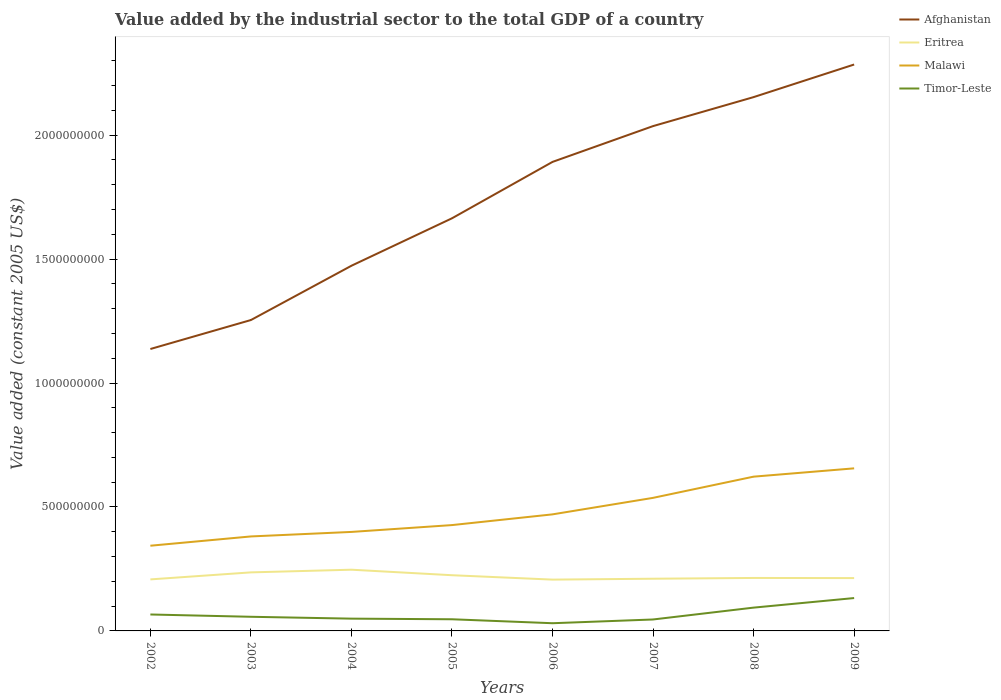How many different coloured lines are there?
Offer a very short reply. 4. Is the number of lines equal to the number of legend labels?
Ensure brevity in your answer.  Yes. Across all years, what is the maximum value added by the industrial sector in Afghanistan?
Your response must be concise. 1.14e+09. What is the total value added by the industrial sector in Timor-Leste in the graph?
Give a very brief answer. -8.56e+07. What is the difference between the highest and the second highest value added by the industrial sector in Afghanistan?
Offer a terse response. 1.15e+09. What is the difference between the highest and the lowest value added by the industrial sector in Timor-Leste?
Your response must be concise. 3. How many years are there in the graph?
Give a very brief answer. 8. What is the difference between two consecutive major ticks on the Y-axis?
Give a very brief answer. 5.00e+08. Are the values on the major ticks of Y-axis written in scientific E-notation?
Keep it short and to the point. No. Does the graph contain any zero values?
Your response must be concise. No. What is the title of the graph?
Make the answer very short. Value added by the industrial sector to the total GDP of a country. What is the label or title of the X-axis?
Offer a terse response. Years. What is the label or title of the Y-axis?
Provide a succinct answer. Value added (constant 2005 US$). What is the Value added (constant 2005 US$) of Afghanistan in 2002?
Offer a terse response. 1.14e+09. What is the Value added (constant 2005 US$) of Eritrea in 2002?
Offer a very short reply. 2.08e+08. What is the Value added (constant 2005 US$) of Malawi in 2002?
Keep it short and to the point. 3.44e+08. What is the Value added (constant 2005 US$) of Timor-Leste in 2002?
Keep it short and to the point. 6.63e+07. What is the Value added (constant 2005 US$) of Afghanistan in 2003?
Your answer should be compact. 1.25e+09. What is the Value added (constant 2005 US$) in Eritrea in 2003?
Make the answer very short. 2.36e+08. What is the Value added (constant 2005 US$) of Malawi in 2003?
Make the answer very short. 3.81e+08. What is the Value added (constant 2005 US$) in Timor-Leste in 2003?
Ensure brevity in your answer.  5.71e+07. What is the Value added (constant 2005 US$) of Afghanistan in 2004?
Your response must be concise. 1.47e+09. What is the Value added (constant 2005 US$) of Eritrea in 2004?
Offer a very short reply. 2.47e+08. What is the Value added (constant 2005 US$) of Malawi in 2004?
Provide a succinct answer. 3.99e+08. What is the Value added (constant 2005 US$) in Timor-Leste in 2004?
Your response must be concise. 4.95e+07. What is the Value added (constant 2005 US$) of Afghanistan in 2005?
Your response must be concise. 1.66e+09. What is the Value added (constant 2005 US$) of Eritrea in 2005?
Ensure brevity in your answer.  2.25e+08. What is the Value added (constant 2005 US$) in Malawi in 2005?
Keep it short and to the point. 4.27e+08. What is the Value added (constant 2005 US$) of Timor-Leste in 2005?
Provide a succinct answer. 4.70e+07. What is the Value added (constant 2005 US$) in Afghanistan in 2006?
Offer a very short reply. 1.89e+09. What is the Value added (constant 2005 US$) of Eritrea in 2006?
Make the answer very short. 2.07e+08. What is the Value added (constant 2005 US$) of Malawi in 2006?
Provide a short and direct response. 4.70e+08. What is the Value added (constant 2005 US$) in Timor-Leste in 2006?
Your answer should be very brief. 3.11e+07. What is the Value added (constant 2005 US$) of Afghanistan in 2007?
Provide a short and direct response. 2.04e+09. What is the Value added (constant 2005 US$) of Eritrea in 2007?
Make the answer very short. 2.11e+08. What is the Value added (constant 2005 US$) in Malawi in 2007?
Your answer should be very brief. 5.37e+08. What is the Value added (constant 2005 US$) of Timor-Leste in 2007?
Ensure brevity in your answer.  4.62e+07. What is the Value added (constant 2005 US$) of Afghanistan in 2008?
Offer a terse response. 2.15e+09. What is the Value added (constant 2005 US$) in Eritrea in 2008?
Ensure brevity in your answer.  2.14e+08. What is the Value added (constant 2005 US$) in Malawi in 2008?
Your answer should be compact. 6.22e+08. What is the Value added (constant 2005 US$) of Timor-Leste in 2008?
Keep it short and to the point. 9.40e+07. What is the Value added (constant 2005 US$) of Afghanistan in 2009?
Provide a succinct answer. 2.29e+09. What is the Value added (constant 2005 US$) of Eritrea in 2009?
Provide a succinct answer. 2.13e+08. What is the Value added (constant 2005 US$) of Malawi in 2009?
Give a very brief answer. 6.56e+08. What is the Value added (constant 2005 US$) of Timor-Leste in 2009?
Ensure brevity in your answer.  1.33e+08. Across all years, what is the maximum Value added (constant 2005 US$) of Afghanistan?
Offer a very short reply. 2.29e+09. Across all years, what is the maximum Value added (constant 2005 US$) in Eritrea?
Make the answer very short. 2.47e+08. Across all years, what is the maximum Value added (constant 2005 US$) in Malawi?
Provide a short and direct response. 6.56e+08. Across all years, what is the maximum Value added (constant 2005 US$) in Timor-Leste?
Your response must be concise. 1.33e+08. Across all years, what is the minimum Value added (constant 2005 US$) in Afghanistan?
Provide a short and direct response. 1.14e+09. Across all years, what is the minimum Value added (constant 2005 US$) in Eritrea?
Your response must be concise. 2.07e+08. Across all years, what is the minimum Value added (constant 2005 US$) in Malawi?
Your response must be concise. 3.44e+08. Across all years, what is the minimum Value added (constant 2005 US$) of Timor-Leste?
Your answer should be compact. 3.11e+07. What is the total Value added (constant 2005 US$) in Afghanistan in the graph?
Ensure brevity in your answer.  1.39e+1. What is the total Value added (constant 2005 US$) in Eritrea in the graph?
Provide a succinct answer. 1.76e+09. What is the total Value added (constant 2005 US$) in Malawi in the graph?
Offer a terse response. 3.84e+09. What is the total Value added (constant 2005 US$) of Timor-Leste in the graph?
Offer a terse response. 5.24e+08. What is the difference between the Value added (constant 2005 US$) of Afghanistan in 2002 and that in 2003?
Offer a terse response. -1.17e+08. What is the difference between the Value added (constant 2005 US$) in Eritrea in 2002 and that in 2003?
Provide a short and direct response. -2.83e+07. What is the difference between the Value added (constant 2005 US$) in Malawi in 2002 and that in 2003?
Offer a very short reply. -3.75e+07. What is the difference between the Value added (constant 2005 US$) in Timor-Leste in 2002 and that in 2003?
Keep it short and to the point. 9.23e+06. What is the difference between the Value added (constant 2005 US$) of Afghanistan in 2002 and that in 2004?
Ensure brevity in your answer.  -3.36e+08. What is the difference between the Value added (constant 2005 US$) in Eritrea in 2002 and that in 2004?
Keep it short and to the point. -3.91e+07. What is the difference between the Value added (constant 2005 US$) of Malawi in 2002 and that in 2004?
Offer a terse response. -5.57e+07. What is the difference between the Value added (constant 2005 US$) in Timor-Leste in 2002 and that in 2004?
Offer a very short reply. 1.68e+07. What is the difference between the Value added (constant 2005 US$) in Afghanistan in 2002 and that in 2005?
Provide a succinct answer. -5.27e+08. What is the difference between the Value added (constant 2005 US$) in Eritrea in 2002 and that in 2005?
Offer a very short reply. -1.69e+07. What is the difference between the Value added (constant 2005 US$) in Malawi in 2002 and that in 2005?
Keep it short and to the point. -8.33e+07. What is the difference between the Value added (constant 2005 US$) in Timor-Leste in 2002 and that in 2005?
Ensure brevity in your answer.  1.93e+07. What is the difference between the Value added (constant 2005 US$) of Afghanistan in 2002 and that in 2006?
Keep it short and to the point. -7.55e+08. What is the difference between the Value added (constant 2005 US$) in Eritrea in 2002 and that in 2006?
Your answer should be very brief. 8.30e+05. What is the difference between the Value added (constant 2005 US$) in Malawi in 2002 and that in 2006?
Make the answer very short. -1.27e+08. What is the difference between the Value added (constant 2005 US$) of Timor-Leste in 2002 and that in 2006?
Your answer should be very brief. 3.52e+07. What is the difference between the Value added (constant 2005 US$) of Afghanistan in 2002 and that in 2007?
Provide a succinct answer. -8.99e+08. What is the difference between the Value added (constant 2005 US$) of Eritrea in 2002 and that in 2007?
Offer a terse response. -2.76e+06. What is the difference between the Value added (constant 2005 US$) of Malawi in 2002 and that in 2007?
Your answer should be very brief. -1.93e+08. What is the difference between the Value added (constant 2005 US$) in Timor-Leste in 2002 and that in 2007?
Offer a very short reply. 2.01e+07. What is the difference between the Value added (constant 2005 US$) of Afghanistan in 2002 and that in 2008?
Your answer should be compact. -1.02e+09. What is the difference between the Value added (constant 2005 US$) of Eritrea in 2002 and that in 2008?
Keep it short and to the point. -5.80e+06. What is the difference between the Value added (constant 2005 US$) of Malawi in 2002 and that in 2008?
Your response must be concise. -2.79e+08. What is the difference between the Value added (constant 2005 US$) of Timor-Leste in 2002 and that in 2008?
Your answer should be compact. -2.77e+07. What is the difference between the Value added (constant 2005 US$) in Afghanistan in 2002 and that in 2009?
Offer a terse response. -1.15e+09. What is the difference between the Value added (constant 2005 US$) of Eritrea in 2002 and that in 2009?
Your answer should be very brief. -5.29e+06. What is the difference between the Value added (constant 2005 US$) in Malawi in 2002 and that in 2009?
Make the answer very short. -3.12e+08. What is the difference between the Value added (constant 2005 US$) of Timor-Leste in 2002 and that in 2009?
Keep it short and to the point. -6.63e+07. What is the difference between the Value added (constant 2005 US$) of Afghanistan in 2003 and that in 2004?
Make the answer very short. -2.19e+08. What is the difference between the Value added (constant 2005 US$) in Eritrea in 2003 and that in 2004?
Make the answer very short. -1.08e+07. What is the difference between the Value added (constant 2005 US$) of Malawi in 2003 and that in 2004?
Offer a very short reply. -1.82e+07. What is the difference between the Value added (constant 2005 US$) in Timor-Leste in 2003 and that in 2004?
Offer a very short reply. 7.55e+06. What is the difference between the Value added (constant 2005 US$) in Afghanistan in 2003 and that in 2005?
Make the answer very short. -4.11e+08. What is the difference between the Value added (constant 2005 US$) of Eritrea in 2003 and that in 2005?
Offer a very short reply. 1.14e+07. What is the difference between the Value added (constant 2005 US$) in Malawi in 2003 and that in 2005?
Provide a short and direct response. -4.58e+07. What is the difference between the Value added (constant 2005 US$) in Timor-Leste in 2003 and that in 2005?
Give a very brief answer. 1.01e+07. What is the difference between the Value added (constant 2005 US$) of Afghanistan in 2003 and that in 2006?
Offer a terse response. -6.38e+08. What is the difference between the Value added (constant 2005 US$) in Eritrea in 2003 and that in 2006?
Provide a short and direct response. 2.92e+07. What is the difference between the Value added (constant 2005 US$) of Malawi in 2003 and that in 2006?
Your answer should be compact. -8.91e+07. What is the difference between the Value added (constant 2005 US$) of Timor-Leste in 2003 and that in 2006?
Ensure brevity in your answer.  2.60e+07. What is the difference between the Value added (constant 2005 US$) in Afghanistan in 2003 and that in 2007?
Provide a short and direct response. -7.83e+08. What is the difference between the Value added (constant 2005 US$) in Eritrea in 2003 and that in 2007?
Provide a succinct answer. 2.56e+07. What is the difference between the Value added (constant 2005 US$) of Malawi in 2003 and that in 2007?
Your answer should be very brief. -1.56e+08. What is the difference between the Value added (constant 2005 US$) of Timor-Leste in 2003 and that in 2007?
Your response must be concise. 1.09e+07. What is the difference between the Value added (constant 2005 US$) of Afghanistan in 2003 and that in 2008?
Your answer should be very brief. -8.99e+08. What is the difference between the Value added (constant 2005 US$) in Eritrea in 2003 and that in 2008?
Provide a short and direct response. 2.25e+07. What is the difference between the Value added (constant 2005 US$) of Malawi in 2003 and that in 2008?
Provide a short and direct response. -2.41e+08. What is the difference between the Value added (constant 2005 US$) of Timor-Leste in 2003 and that in 2008?
Provide a succinct answer. -3.69e+07. What is the difference between the Value added (constant 2005 US$) of Afghanistan in 2003 and that in 2009?
Make the answer very short. -1.03e+09. What is the difference between the Value added (constant 2005 US$) in Eritrea in 2003 and that in 2009?
Provide a short and direct response. 2.30e+07. What is the difference between the Value added (constant 2005 US$) in Malawi in 2003 and that in 2009?
Make the answer very short. -2.75e+08. What is the difference between the Value added (constant 2005 US$) in Timor-Leste in 2003 and that in 2009?
Your answer should be compact. -7.55e+07. What is the difference between the Value added (constant 2005 US$) of Afghanistan in 2004 and that in 2005?
Keep it short and to the point. -1.91e+08. What is the difference between the Value added (constant 2005 US$) of Eritrea in 2004 and that in 2005?
Provide a succinct answer. 2.22e+07. What is the difference between the Value added (constant 2005 US$) of Malawi in 2004 and that in 2005?
Offer a very short reply. -2.76e+07. What is the difference between the Value added (constant 2005 US$) of Timor-Leste in 2004 and that in 2005?
Your answer should be compact. 2.52e+06. What is the difference between the Value added (constant 2005 US$) of Afghanistan in 2004 and that in 2006?
Provide a short and direct response. -4.19e+08. What is the difference between the Value added (constant 2005 US$) in Eritrea in 2004 and that in 2006?
Ensure brevity in your answer.  4.00e+07. What is the difference between the Value added (constant 2005 US$) of Malawi in 2004 and that in 2006?
Provide a succinct answer. -7.08e+07. What is the difference between the Value added (constant 2005 US$) of Timor-Leste in 2004 and that in 2006?
Make the answer very short. 1.85e+07. What is the difference between the Value added (constant 2005 US$) of Afghanistan in 2004 and that in 2007?
Provide a short and direct response. -5.63e+08. What is the difference between the Value added (constant 2005 US$) in Eritrea in 2004 and that in 2007?
Your answer should be compact. 3.64e+07. What is the difference between the Value added (constant 2005 US$) in Malawi in 2004 and that in 2007?
Provide a succinct answer. -1.37e+08. What is the difference between the Value added (constant 2005 US$) in Timor-Leste in 2004 and that in 2007?
Your response must be concise. 3.36e+06. What is the difference between the Value added (constant 2005 US$) in Afghanistan in 2004 and that in 2008?
Your answer should be compact. -6.80e+08. What is the difference between the Value added (constant 2005 US$) of Eritrea in 2004 and that in 2008?
Your answer should be very brief. 3.33e+07. What is the difference between the Value added (constant 2005 US$) in Malawi in 2004 and that in 2008?
Ensure brevity in your answer.  -2.23e+08. What is the difference between the Value added (constant 2005 US$) of Timor-Leste in 2004 and that in 2008?
Your response must be concise. -4.45e+07. What is the difference between the Value added (constant 2005 US$) of Afghanistan in 2004 and that in 2009?
Ensure brevity in your answer.  -8.12e+08. What is the difference between the Value added (constant 2005 US$) in Eritrea in 2004 and that in 2009?
Make the answer very short. 3.38e+07. What is the difference between the Value added (constant 2005 US$) of Malawi in 2004 and that in 2009?
Offer a very short reply. -2.57e+08. What is the difference between the Value added (constant 2005 US$) of Timor-Leste in 2004 and that in 2009?
Make the answer very short. -8.31e+07. What is the difference between the Value added (constant 2005 US$) in Afghanistan in 2005 and that in 2006?
Give a very brief answer. -2.28e+08. What is the difference between the Value added (constant 2005 US$) of Eritrea in 2005 and that in 2006?
Keep it short and to the point. 1.77e+07. What is the difference between the Value added (constant 2005 US$) in Malawi in 2005 and that in 2006?
Give a very brief answer. -4.33e+07. What is the difference between the Value added (constant 2005 US$) of Timor-Leste in 2005 and that in 2006?
Make the answer very short. 1.59e+07. What is the difference between the Value added (constant 2005 US$) in Afghanistan in 2005 and that in 2007?
Offer a very short reply. -3.72e+08. What is the difference between the Value added (constant 2005 US$) of Eritrea in 2005 and that in 2007?
Provide a succinct answer. 1.41e+07. What is the difference between the Value added (constant 2005 US$) of Malawi in 2005 and that in 2007?
Ensure brevity in your answer.  -1.10e+08. What is the difference between the Value added (constant 2005 US$) in Timor-Leste in 2005 and that in 2007?
Your response must be concise. 8.39e+05. What is the difference between the Value added (constant 2005 US$) of Afghanistan in 2005 and that in 2008?
Your answer should be very brief. -4.89e+08. What is the difference between the Value added (constant 2005 US$) in Eritrea in 2005 and that in 2008?
Offer a terse response. 1.11e+07. What is the difference between the Value added (constant 2005 US$) in Malawi in 2005 and that in 2008?
Your answer should be compact. -1.95e+08. What is the difference between the Value added (constant 2005 US$) in Timor-Leste in 2005 and that in 2008?
Give a very brief answer. -4.70e+07. What is the difference between the Value added (constant 2005 US$) in Afghanistan in 2005 and that in 2009?
Offer a terse response. -6.20e+08. What is the difference between the Value added (constant 2005 US$) of Eritrea in 2005 and that in 2009?
Ensure brevity in your answer.  1.16e+07. What is the difference between the Value added (constant 2005 US$) of Malawi in 2005 and that in 2009?
Keep it short and to the point. -2.29e+08. What is the difference between the Value added (constant 2005 US$) of Timor-Leste in 2005 and that in 2009?
Make the answer very short. -8.56e+07. What is the difference between the Value added (constant 2005 US$) in Afghanistan in 2006 and that in 2007?
Offer a terse response. -1.44e+08. What is the difference between the Value added (constant 2005 US$) of Eritrea in 2006 and that in 2007?
Offer a terse response. -3.59e+06. What is the difference between the Value added (constant 2005 US$) in Malawi in 2006 and that in 2007?
Provide a succinct answer. -6.66e+07. What is the difference between the Value added (constant 2005 US$) of Timor-Leste in 2006 and that in 2007?
Give a very brief answer. -1.51e+07. What is the difference between the Value added (constant 2005 US$) in Afghanistan in 2006 and that in 2008?
Make the answer very short. -2.61e+08. What is the difference between the Value added (constant 2005 US$) in Eritrea in 2006 and that in 2008?
Provide a succinct answer. -6.63e+06. What is the difference between the Value added (constant 2005 US$) of Malawi in 2006 and that in 2008?
Your answer should be very brief. -1.52e+08. What is the difference between the Value added (constant 2005 US$) in Timor-Leste in 2006 and that in 2008?
Your answer should be compact. -6.29e+07. What is the difference between the Value added (constant 2005 US$) in Afghanistan in 2006 and that in 2009?
Provide a short and direct response. -3.93e+08. What is the difference between the Value added (constant 2005 US$) in Eritrea in 2006 and that in 2009?
Give a very brief answer. -6.12e+06. What is the difference between the Value added (constant 2005 US$) in Malawi in 2006 and that in 2009?
Provide a succinct answer. -1.86e+08. What is the difference between the Value added (constant 2005 US$) in Timor-Leste in 2006 and that in 2009?
Make the answer very short. -1.02e+08. What is the difference between the Value added (constant 2005 US$) of Afghanistan in 2007 and that in 2008?
Offer a terse response. -1.17e+08. What is the difference between the Value added (constant 2005 US$) of Eritrea in 2007 and that in 2008?
Provide a succinct answer. -3.04e+06. What is the difference between the Value added (constant 2005 US$) of Malawi in 2007 and that in 2008?
Provide a short and direct response. -8.56e+07. What is the difference between the Value added (constant 2005 US$) in Timor-Leste in 2007 and that in 2008?
Offer a terse response. -4.78e+07. What is the difference between the Value added (constant 2005 US$) of Afghanistan in 2007 and that in 2009?
Give a very brief answer. -2.48e+08. What is the difference between the Value added (constant 2005 US$) of Eritrea in 2007 and that in 2009?
Offer a very short reply. -2.52e+06. What is the difference between the Value added (constant 2005 US$) in Malawi in 2007 and that in 2009?
Keep it short and to the point. -1.19e+08. What is the difference between the Value added (constant 2005 US$) in Timor-Leste in 2007 and that in 2009?
Keep it short and to the point. -8.64e+07. What is the difference between the Value added (constant 2005 US$) in Afghanistan in 2008 and that in 2009?
Offer a terse response. -1.32e+08. What is the difference between the Value added (constant 2005 US$) of Eritrea in 2008 and that in 2009?
Make the answer very short. 5.18e+05. What is the difference between the Value added (constant 2005 US$) in Malawi in 2008 and that in 2009?
Provide a succinct answer. -3.35e+07. What is the difference between the Value added (constant 2005 US$) of Timor-Leste in 2008 and that in 2009?
Provide a succinct answer. -3.86e+07. What is the difference between the Value added (constant 2005 US$) of Afghanistan in 2002 and the Value added (constant 2005 US$) of Eritrea in 2003?
Your answer should be very brief. 9.01e+08. What is the difference between the Value added (constant 2005 US$) of Afghanistan in 2002 and the Value added (constant 2005 US$) of Malawi in 2003?
Give a very brief answer. 7.56e+08. What is the difference between the Value added (constant 2005 US$) in Afghanistan in 2002 and the Value added (constant 2005 US$) in Timor-Leste in 2003?
Your answer should be very brief. 1.08e+09. What is the difference between the Value added (constant 2005 US$) in Eritrea in 2002 and the Value added (constant 2005 US$) in Malawi in 2003?
Keep it short and to the point. -1.73e+08. What is the difference between the Value added (constant 2005 US$) in Eritrea in 2002 and the Value added (constant 2005 US$) in Timor-Leste in 2003?
Your response must be concise. 1.51e+08. What is the difference between the Value added (constant 2005 US$) in Malawi in 2002 and the Value added (constant 2005 US$) in Timor-Leste in 2003?
Ensure brevity in your answer.  2.87e+08. What is the difference between the Value added (constant 2005 US$) in Afghanistan in 2002 and the Value added (constant 2005 US$) in Eritrea in 2004?
Ensure brevity in your answer.  8.90e+08. What is the difference between the Value added (constant 2005 US$) in Afghanistan in 2002 and the Value added (constant 2005 US$) in Malawi in 2004?
Make the answer very short. 7.38e+08. What is the difference between the Value added (constant 2005 US$) in Afghanistan in 2002 and the Value added (constant 2005 US$) in Timor-Leste in 2004?
Offer a very short reply. 1.09e+09. What is the difference between the Value added (constant 2005 US$) of Eritrea in 2002 and the Value added (constant 2005 US$) of Malawi in 2004?
Make the answer very short. -1.92e+08. What is the difference between the Value added (constant 2005 US$) of Eritrea in 2002 and the Value added (constant 2005 US$) of Timor-Leste in 2004?
Keep it short and to the point. 1.58e+08. What is the difference between the Value added (constant 2005 US$) in Malawi in 2002 and the Value added (constant 2005 US$) in Timor-Leste in 2004?
Your answer should be very brief. 2.94e+08. What is the difference between the Value added (constant 2005 US$) of Afghanistan in 2002 and the Value added (constant 2005 US$) of Eritrea in 2005?
Provide a short and direct response. 9.13e+08. What is the difference between the Value added (constant 2005 US$) of Afghanistan in 2002 and the Value added (constant 2005 US$) of Malawi in 2005?
Your response must be concise. 7.10e+08. What is the difference between the Value added (constant 2005 US$) in Afghanistan in 2002 and the Value added (constant 2005 US$) in Timor-Leste in 2005?
Keep it short and to the point. 1.09e+09. What is the difference between the Value added (constant 2005 US$) of Eritrea in 2002 and the Value added (constant 2005 US$) of Malawi in 2005?
Your answer should be very brief. -2.19e+08. What is the difference between the Value added (constant 2005 US$) in Eritrea in 2002 and the Value added (constant 2005 US$) in Timor-Leste in 2005?
Provide a short and direct response. 1.61e+08. What is the difference between the Value added (constant 2005 US$) in Malawi in 2002 and the Value added (constant 2005 US$) in Timor-Leste in 2005?
Offer a very short reply. 2.97e+08. What is the difference between the Value added (constant 2005 US$) in Afghanistan in 2002 and the Value added (constant 2005 US$) in Eritrea in 2006?
Ensure brevity in your answer.  9.30e+08. What is the difference between the Value added (constant 2005 US$) of Afghanistan in 2002 and the Value added (constant 2005 US$) of Malawi in 2006?
Offer a very short reply. 6.67e+08. What is the difference between the Value added (constant 2005 US$) in Afghanistan in 2002 and the Value added (constant 2005 US$) in Timor-Leste in 2006?
Make the answer very short. 1.11e+09. What is the difference between the Value added (constant 2005 US$) in Eritrea in 2002 and the Value added (constant 2005 US$) in Malawi in 2006?
Your answer should be compact. -2.62e+08. What is the difference between the Value added (constant 2005 US$) of Eritrea in 2002 and the Value added (constant 2005 US$) of Timor-Leste in 2006?
Offer a terse response. 1.77e+08. What is the difference between the Value added (constant 2005 US$) of Malawi in 2002 and the Value added (constant 2005 US$) of Timor-Leste in 2006?
Your answer should be compact. 3.13e+08. What is the difference between the Value added (constant 2005 US$) of Afghanistan in 2002 and the Value added (constant 2005 US$) of Eritrea in 2007?
Ensure brevity in your answer.  9.27e+08. What is the difference between the Value added (constant 2005 US$) of Afghanistan in 2002 and the Value added (constant 2005 US$) of Malawi in 2007?
Your response must be concise. 6.01e+08. What is the difference between the Value added (constant 2005 US$) in Afghanistan in 2002 and the Value added (constant 2005 US$) in Timor-Leste in 2007?
Give a very brief answer. 1.09e+09. What is the difference between the Value added (constant 2005 US$) in Eritrea in 2002 and the Value added (constant 2005 US$) in Malawi in 2007?
Offer a very short reply. -3.29e+08. What is the difference between the Value added (constant 2005 US$) in Eritrea in 2002 and the Value added (constant 2005 US$) in Timor-Leste in 2007?
Provide a short and direct response. 1.62e+08. What is the difference between the Value added (constant 2005 US$) of Malawi in 2002 and the Value added (constant 2005 US$) of Timor-Leste in 2007?
Your response must be concise. 2.98e+08. What is the difference between the Value added (constant 2005 US$) of Afghanistan in 2002 and the Value added (constant 2005 US$) of Eritrea in 2008?
Make the answer very short. 9.24e+08. What is the difference between the Value added (constant 2005 US$) of Afghanistan in 2002 and the Value added (constant 2005 US$) of Malawi in 2008?
Provide a succinct answer. 5.15e+08. What is the difference between the Value added (constant 2005 US$) of Afghanistan in 2002 and the Value added (constant 2005 US$) of Timor-Leste in 2008?
Keep it short and to the point. 1.04e+09. What is the difference between the Value added (constant 2005 US$) of Eritrea in 2002 and the Value added (constant 2005 US$) of Malawi in 2008?
Provide a short and direct response. -4.15e+08. What is the difference between the Value added (constant 2005 US$) in Eritrea in 2002 and the Value added (constant 2005 US$) in Timor-Leste in 2008?
Offer a terse response. 1.14e+08. What is the difference between the Value added (constant 2005 US$) of Malawi in 2002 and the Value added (constant 2005 US$) of Timor-Leste in 2008?
Ensure brevity in your answer.  2.50e+08. What is the difference between the Value added (constant 2005 US$) of Afghanistan in 2002 and the Value added (constant 2005 US$) of Eritrea in 2009?
Your answer should be very brief. 9.24e+08. What is the difference between the Value added (constant 2005 US$) in Afghanistan in 2002 and the Value added (constant 2005 US$) in Malawi in 2009?
Keep it short and to the point. 4.81e+08. What is the difference between the Value added (constant 2005 US$) of Afghanistan in 2002 and the Value added (constant 2005 US$) of Timor-Leste in 2009?
Your answer should be compact. 1.00e+09. What is the difference between the Value added (constant 2005 US$) of Eritrea in 2002 and the Value added (constant 2005 US$) of Malawi in 2009?
Offer a very short reply. -4.48e+08. What is the difference between the Value added (constant 2005 US$) of Eritrea in 2002 and the Value added (constant 2005 US$) of Timor-Leste in 2009?
Your answer should be very brief. 7.53e+07. What is the difference between the Value added (constant 2005 US$) in Malawi in 2002 and the Value added (constant 2005 US$) in Timor-Leste in 2009?
Give a very brief answer. 2.11e+08. What is the difference between the Value added (constant 2005 US$) in Afghanistan in 2003 and the Value added (constant 2005 US$) in Eritrea in 2004?
Provide a succinct answer. 1.01e+09. What is the difference between the Value added (constant 2005 US$) in Afghanistan in 2003 and the Value added (constant 2005 US$) in Malawi in 2004?
Your response must be concise. 8.55e+08. What is the difference between the Value added (constant 2005 US$) in Afghanistan in 2003 and the Value added (constant 2005 US$) in Timor-Leste in 2004?
Your answer should be compact. 1.20e+09. What is the difference between the Value added (constant 2005 US$) in Eritrea in 2003 and the Value added (constant 2005 US$) in Malawi in 2004?
Your response must be concise. -1.63e+08. What is the difference between the Value added (constant 2005 US$) of Eritrea in 2003 and the Value added (constant 2005 US$) of Timor-Leste in 2004?
Offer a very short reply. 1.87e+08. What is the difference between the Value added (constant 2005 US$) in Malawi in 2003 and the Value added (constant 2005 US$) in Timor-Leste in 2004?
Offer a terse response. 3.32e+08. What is the difference between the Value added (constant 2005 US$) in Afghanistan in 2003 and the Value added (constant 2005 US$) in Eritrea in 2005?
Offer a very short reply. 1.03e+09. What is the difference between the Value added (constant 2005 US$) of Afghanistan in 2003 and the Value added (constant 2005 US$) of Malawi in 2005?
Your answer should be compact. 8.27e+08. What is the difference between the Value added (constant 2005 US$) of Afghanistan in 2003 and the Value added (constant 2005 US$) of Timor-Leste in 2005?
Keep it short and to the point. 1.21e+09. What is the difference between the Value added (constant 2005 US$) of Eritrea in 2003 and the Value added (constant 2005 US$) of Malawi in 2005?
Keep it short and to the point. -1.91e+08. What is the difference between the Value added (constant 2005 US$) in Eritrea in 2003 and the Value added (constant 2005 US$) in Timor-Leste in 2005?
Keep it short and to the point. 1.89e+08. What is the difference between the Value added (constant 2005 US$) of Malawi in 2003 and the Value added (constant 2005 US$) of Timor-Leste in 2005?
Offer a terse response. 3.34e+08. What is the difference between the Value added (constant 2005 US$) in Afghanistan in 2003 and the Value added (constant 2005 US$) in Eritrea in 2006?
Your answer should be very brief. 1.05e+09. What is the difference between the Value added (constant 2005 US$) of Afghanistan in 2003 and the Value added (constant 2005 US$) of Malawi in 2006?
Provide a succinct answer. 7.84e+08. What is the difference between the Value added (constant 2005 US$) in Afghanistan in 2003 and the Value added (constant 2005 US$) in Timor-Leste in 2006?
Ensure brevity in your answer.  1.22e+09. What is the difference between the Value added (constant 2005 US$) of Eritrea in 2003 and the Value added (constant 2005 US$) of Malawi in 2006?
Provide a succinct answer. -2.34e+08. What is the difference between the Value added (constant 2005 US$) in Eritrea in 2003 and the Value added (constant 2005 US$) in Timor-Leste in 2006?
Provide a succinct answer. 2.05e+08. What is the difference between the Value added (constant 2005 US$) in Malawi in 2003 and the Value added (constant 2005 US$) in Timor-Leste in 2006?
Provide a succinct answer. 3.50e+08. What is the difference between the Value added (constant 2005 US$) of Afghanistan in 2003 and the Value added (constant 2005 US$) of Eritrea in 2007?
Your answer should be very brief. 1.04e+09. What is the difference between the Value added (constant 2005 US$) in Afghanistan in 2003 and the Value added (constant 2005 US$) in Malawi in 2007?
Keep it short and to the point. 7.17e+08. What is the difference between the Value added (constant 2005 US$) of Afghanistan in 2003 and the Value added (constant 2005 US$) of Timor-Leste in 2007?
Keep it short and to the point. 1.21e+09. What is the difference between the Value added (constant 2005 US$) in Eritrea in 2003 and the Value added (constant 2005 US$) in Malawi in 2007?
Make the answer very short. -3.01e+08. What is the difference between the Value added (constant 2005 US$) of Eritrea in 2003 and the Value added (constant 2005 US$) of Timor-Leste in 2007?
Provide a short and direct response. 1.90e+08. What is the difference between the Value added (constant 2005 US$) in Malawi in 2003 and the Value added (constant 2005 US$) in Timor-Leste in 2007?
Offer a terse response. 3.35e+08. What is the difference between the Value added (constant 2005 US$) in Afghanistan in 2003 and the Value added (constant 2005 US$) in Eritrea in 2008?
Ensure brevity in your answer.  1.04e+09. What is the difference between the Value added (constant 2005 US$) of Afghanistan in 2003 and the Value added (constant 2005 US$) of Malawi in 2008?
Keep it short and to the point. 6.32e+08. What is the difference between the Value added (constant 2005 US$) in Afghanistan in 2003 and the Value added (constant 2005 US$) in Timor-Leste in 2008?
Offer a terse response. 1.16e+09. What is the difference between the Value added (constant 2005 US$) of Eritrea in 2003 and the Value added (constant 2005 US$) of Malawi in 2008?
Offer a very short reply. -3.86e+08. What is the difference between the Value added (constant 2005 US$) in Eritrea in 2003 and the Value added (constant 2005 US$) in Timor-Leste in 2008?
Make the answer very short. 1.42e+08. What is the difference between the Value added (constant 2005 US$) of Malawi in 2003 and the Value added (constant 2005 US$) of Timor-Leste in 2008?
Ensure brevity in your answer.  2.87e+08. What is the difference between the Value added (constant 2005 US$) of Afghanistan in 2003 and the Value added (constant 2005 US$) of Eritrea in 2009?
Make the answer very short. 1.04e+09. What is the difference between the Value added (constant 2005 US$) in Afghanistan in 2003 and the Value added (constant 2005 US$) in Malawi in 2009?
Ensure brevity in your answer.  5.98e+08. What is the difference between the Value added (constant 2005 US$) of Afghanistan in 2003 and the Value added (constant 2005 US$) of Timor-Leste in 2009?
Offer a terse response. 1.12e+09. What is the difference between the Value added (constant 2005 US$) of Eritrea in 2003 and the Value added (constant 2005 US$) of Malawi in 2009?
Make the answer very short. -4.20e+08. What is the difference between the Value added (constant 2005 US$) of Eritrea in 2003 and the Value added (constant 2005 US$) of Timor-Leste in 2009?
Keep it short and to the point. 1.04e+08. What is the difference between the Value added (constant 2005 US$) in Malawi in 2003 and the Value added (constant 2005 US$) in Timor-Leste in 2009?
Give a very brief answer. 2.49e+08. What is the difference between the Value added (constant 2005 US$) of Afghanistan in 2004 and the Value added (constant 2005 US$) of Eritrea in 2005?
Offer a terse response. 1.25e+09. What is the difference between the Value added (constant 2005 US$) of Afghanistan in 2004 and the Value added (constant 2005 US$) of Malawi in 2005?
Provide a short and direct response. 1.05e+09. What is the difference between the Value added (constant 2005 US$) in Afghanistan in 2004 and the Value added (constant 2005 US$) in Timor-Leste in 2005?
Offer a very short reply. 1.43e+09. What is the difference between the Value added (constant 2005 US$) in Eritrea in 2004 and the Value added (constant 2005 US$) in Malawi in 2005?
Your response must be concise. -1.80e+08. What is the difference between the Value added (constant 2005 US$) of Eritrea in 2004 and the Value added (constant 2005 US$) of Timor-Leste in 2005?
Provide a short and direct response. 2.00e+08. What is the difference between the Value added (constant 2005 US$) in Malawi in 2004 and the Value added (constant 2005 US$) in Timor-Leste in 2005?
Offer a very short reply. 3.52e+08. What is the difference between the Value added (constant 2005 US$) in Afghanistan in 2004 and the Value added (constant 2005 US$) in Eritrea in 2006?
Offer a very short reply. 1.27e+09. What is the difference between the Value added (constant 2005 US$) in Afghanistan in 2004 and the Value added (constant 2005 US$) in Malawi in 2006?
Give a very brief answer. 1.00e+09. What is the difference between the Value added (constant 2005 US$) of Afghanistan in 2004 and the Value added (constant 2005 US$) of Timor-Leste in 2006?
Ensure brevity in your answer.  1.44e+09. What is the difference between the Value added (constant 2005 US$) of Eritrea in 2004 and the Value added (constant 2005 US$) of Malawi in 2006?
Your answer should be compact. -2.23e+08. What is the difference between the Value added (constant 2005 US$) in Eritrea in 2004 and the Value added (constant 2005 US$) in Timor-Leste in 2006?
Ensure brevity in your answer.  2.16e+08. What is the difference between the Value added (constant 2005 US$) of Malawi in 2004 and the Value added (constant 2005 US$) of Timor-Leste in 2006?
Give a very brief answer. 3.68e+08. What is the difference between the Value added (constant 2005 US$) in Afghanistan in 2004 and the Value added (constant 2005 US$) in Eritrea in 2007?
Offer a very short reply. 1.26e+09. What is the difference between the Value added (constant 2005 US$) of Afghanistan in 2004 and the Value added (constant 2005 US$) of Malawi in 2007?
Make the answer very short. 9.37e+08. What is the difference between the Value added (constant 2005 US$) of Afghanistan in 2004 and the Value added (constant 2005 US$) of Timor-Leste in 2007?
Your response must be concise. 1.43e+09. What is the difference between the Value added (constant 2005 US$) in Eritrea in 2004 and the Value added (constant 2005 US$) in Malawi in 2007?
Offer a terse response. -2.90e+08. What is the difference between the Value added (constant 2005 US$) in Eritrea in 2004 and the Value added (constant 2005 US$) in Timor-Leste in 2007?
Your answer should be very brief. 2.01e+08. What is the difference between the Value added (constant 2005 US$) in Malawi in 2004 and the Value added (constant 2005 US$) in Timor-Leste in 2007?
Your answer should be compact. 3.53e+08. What is the difference between the Value added (constant 2005 US$) of Afghanistan in 2004 and the Value added (constant 2005 US$) of Eritrea in 2008?
Offer a terse response. 1.26e+09. What is the difference between the Value added (constant 2005 US$) of Afghanistan in 2004 and the Value added (constant 2005 US$) of Malawi in 2008?
Keep it short and to the point. 8.51e+08. What is the difference between the Value added (constant 2005 US$) of Afghanistan in 2004 and the Value added (constant 2005 US$) of Timor-Leste in 2008?
Keep it short and to the point. 1.38e+09. What is the difference between the Value added (constant 2005 US$) in Eritrea in 2004 and the Value added (constant 2005 US$) in Malawi in 2008?
Your answer should be very brief. -3.75e+08. What is the difference between the Value added (constant 2005 US$) of Eritrea in 2004 and the Value added (constant 2005 US$) of Timor-Leste in 2008?
Offer a terse response. 1.53e+08. What is the difference between the Value added (constant 2005 US$) of Malawi in 2004 and the Value added (constant 2005 US$) of Timor-Leste in 2008?
Make the answer very short. 3.05e+08. What is the difference between the Value added (constant 2005 US$) of Afghanistan in 2004 and the Value added (constant 2005 US$) of Eritrea in 2009?
Your answer should be compact. 1.26e+09. What is the difference between the Value added (constant 2005 US$) of Afghanistan in 2004 and the Value added (constant 2005 US$) of Malawi in 2009?
Your answer should be very brief. 8.17e+08. What is the difference between the Value added (constant 2005 US$) in Afghanistan in 2004 and the Value added (constant 2005 US$) in Timor-Leste in 2009?
Make the answer very short. 1.34e+09. What is the difference between the Value added (constant 2005 US$) of Eritrea in 2004 and the Value added (constant 2005 US$) of Malawi in 2009?
Your answer should be very brief. -4.09e+08. What is the difference between the Value added (constant 2005 US$) in Eritrea in 2004 and the Value added (constant 2005 US$) in Timor-Leste in 2009?
Make the answer very short. 1.14e+08. What is the difference between the Value added (constant 2005 US$) in Malawi in 2004 and the Value added (constant 2005 US$) in Timor-Leste in 2009?
Offer a very short reply. 2.67e+08. What is the difference between the Value added (constant 2005 US$) of Afghanistan in 2005 and the Value added (constant 2005 US$) of Eritrea in 2006?
Give a very brief answer. 1.46e+09. What is the difference between the Value added (constant 2005 US$) of Afghanistan in 2005 and the Value added (constant 2005 US$) of Malawi in 2006?
Your response must be concise. 1.19e+09. What is the difference between the Value added (constant 2005 US$) of Afghanistan in 2005 and the Value added (constant 2005 US$) of Timor-Leste in 2006?
Provide a short and direct response. 1.63e+09. What is the difference between the Value added (constant 2005 US$) in Eritrea in 2005 and the Value added (constant 2005 US$) in Malawi in 2006?
Make the answer very short. -2.46e+08. What is the difference between the Value added (constant 2005 US$) in Eritrea in 2005 and the Value added (constant 2005 US$) in Timor-Leste in 2006?
Provide a short and direct response. 1.94e+08. What is the difference between the Value added (constant 2005 US$) of Malawi in 2005 and the Value added (constant 2005 US$) of Timor-Leste in 2006?
Your answer should be compact. 3.96e+08. What is the difference between the Value added (constant 2005 US$) of Afghanistan in 2005 and the Value added (constant 2005 US$) of Eritrea in 2007?
Your answer should be compact. 1.45e+09. What is the difference between the Value added (constant 2005 US$) in Afghanistan in 2005 and the Value added (constant 2005 US$) in Malawi in 2007?
Ensure brevity in your answer.  1.13e+09. What is the difference between the Value added (constant 2005 US$) of Afghanistan in 2005 and the Value added (constant 2005 US$) of Timor-Leste in 2007?
Your answer should be very brief. 1.62e+09. What is the difference between the Value added (constant 2005 US$) in Eritrea in 2005 and the Value added (constant 2005 US$) in Malawi in 2007?
Offer a terse response. -3.12e+08. What is the difference between the Value added (constant 2005 US$) of Eritrea in 2005 and the Value added (constant 2005 US$) of Timor-Leste in 2007?
Your response must be concise. 1.79e+08. What is the difference between the Value added (constant 2005 US$) in Malawi in 2005 and the Value added (constant 2005 US$) in Timor-Leste in 2007?
Keep it short and to the point. 3.81e+08. What is the difference between the Value added (constant 2005 US$) of Afghanistan in 2005 and the Value added (constant 2005 US$) of Eritrea in 2008?
Provide a short and direct response. 1.45e+09. What is the difference between the Value added (constant 2005 US$) in Afghanistan in 2005 and the Value added (constant 2005 US$) in Malawi in 2008?
Make the answer very short. 1.04e+09. What is the difference between the Value added (constant 2005 US$) in Afghanistan in 2005 and the Value added (constant 2005 US$) in Timor-Leste in 2008?
Offer a terse response. 1.57e+09. What is the difference between the Value added (constant 2005 US$) in Eritrea in 2005 and the Value added (constant 2005 US$) in Malawi in 2008?
Your answer should be very brief. -3.98e+08. What is the difference between the Value added (constant 2005 US$) in Eritrea in 2005 and the Value added (constant 2005 US$) in Timor-Leste in 2008?
Provide a short and direct response. 1.31e+08. What is the difference between the Value added (constant 2005 US$) in Malawi in 2005 and the Value added (constant 2005 US$) in Timor-Leste in 2008?
Give a very brief answer. 3.33e+08. What is the difference between the Value added (constant 2005 US$) in Afghanistan in 2005 and the Value added (constant 2005 US$) in Eritrea in 2009?
Your answer should be compact. 1.45e+09. What is the difference between the Value added (constant 2005 US$) in Afghanistan in 2005 and the Value added (constant 2005 US$) in Malawi in 2009?
Your answer should be compact. 1.01e+09. What is the difference between the Value added (constant 2005 US$) in Afghanistan in 2005 and the Value added (constant 2005 US$) in Timor-Leste in 2009?
Keep it short and to the point. 1.53e+09. What is the difference between the Value added (constant 2005 US$) of Eritrea in 2005 and the Value added (constant 2005 US$) of Malawi in 2009?
Your answer should be compact. -4.31e+08. What is the difference between the Value added (constant 2005 US$) in Eritrea in 2005 and the Value added (constant 2005 US$) in Timor-Leste in 2009?
Offer a terse response. 9.22e+07. What is the difference between the Value added (constant 2005 US$) of Malawi in 2005 and the Value added (constant 2005 US$) of Timor-Leste in 2009?
Offer a very short reply. 2.94e+08. What is the difference between the Value added (constant 2005 US$) of Afghanistan in 2006 and the Value added (constant 2005 US$) of Eritrea in 2007?
Offer a terse response. 1.68e+09. What is the difference between the Value added (constant 2005 US$) in Afghanistan in 2006 and the Value added (constant 2005 US$) in Malawi in 2007?
Provide a succinct answer. 1.36e+09. What is the difference between the Value added (constant 2005 US$) in Afghanistan in 2006 and the Value added (constant 2005 US$) in Timor-Leste in 2007?
Provide a short and direct response. 1.85e+09. What is the difference between the Value added (constant 2005 US$) of Eritrea in 2006 and the Value added (constant 2005 US$) of Malawi in 2007?
Keep it short and to the point. -3.30e+08. What is the difference between the Value added (constant 2005 US$) in Eritrea in 2006 and the Value added (constant 2005 US$) in Timor-Leste in 2007?
Your answer should be compact. 1.61e+08. What is the difference between the Value added (constant 2005 US$) in Malawi in 2006 and the Value added (constant 2005 US$) in Timor-Leste in 2007?
Your answer should be compact. 4.24e+08. What is the difference between the Value added (constant 2005 US$) in Afghanistan in 2006 and the Value added (constant 2005 US$) in Eritrea in 2008?
Offer a very short reply. 1.68e+09. What is the difference between the Value added (constant 2005 US$) in Afghanistan in 2006 and the Value added (constant 2005 US$) in Malawi in 2008?
Make the answer very short. 1.27e+09. What is the difference between the Value added (constant 2005 US$) of Afghanistan in 2006 and the Value added (constant 2005 US$) of Timor-Leste in 2008?
Ensure brevity in your answer.  1.80e+09. What is the difference between the Value added (constant 2005 US$) in Eritrea in 2006 and the Value added (constant 2005 US$) in Malawi in 2008?
Provide a short and direct response. -4.15e+08. What is the difference between the Value added (constant 2005 US$) in Eritrea in 2006 and the Value added (constant 2005 US$) in Timor-Leste in 2008?
Make the answer very short. 1.13e+08. What is the difference between the Value added (constant 2005 US$) in Malawi in 2006 and the Value added (constant 2005 US$) in Timor-Leste in 2008?
Offer a very short reply. 3.76e+08. What is the difference between the Value added (constant 2005 US$) of Afghanistan in 2006 and the Value added (constant 2005 US$) of Eritrea in 2009?
Your response must be concise. 1.68e+09. What is the difference between the Value added (constant 2005 US$) in Afghanistan in 2006 and the Value added (constant 2005 US$) in Malawi in 2009?
Keep it short and to the point. 1.24e+09. What is the difference between the Value added (constant 2005 US$) of Afghanistan in 2006 and the Value added (constant 2005 US$) of Timor-Leste in 2009?
Keep it short and to the point. 1.76e+09. What is the difference between the Value added (constant 2005 US$) of Eritrea in 2006 and the Value added (constant 2005 US$) of Malawi in 2009?
Your answer should be compact. -4.49e+08. What is the difference between the Value added (constant 2005 US$) in Eritrea in 2006 and the Value added (constant 2005 US$) in Timor-Leste in 2009?
Provide a short and direct response. 7.44e+07. What is the difference between the Value added (constant 2005 US$) in Malawi in 2006 and the Value added (constant 2005 US$) in Timor-Leste in 2009?
Your response must be concise. 3.38e+08. What is the difference between the Value added (constant 2005 US$) of Afghanistan in 2007 and the Value added (constant 2005 US$) of Eritrea in 2008?
Keep it short and to the point. 1.82e+09. What is the difference between the Value added (constant 2005 US$) in Afghanistan in 2007 and the Value added (constant 2005 US$) in Malawi in 2008?
Give a very brief answer. 1.41e+09. What is the difference between the Value added (constant 2005 US$) of Afghanistan in 2007 and the Value added (constant 2005 US$) of Timor-Leste in 2008?
Make the answer very short. 1.94e+09. What is the difference between the Value added (constant 2005 US$) in Eritrea in 2007 and the Value added (constant 2005 US$) in Malawi in 2008?
Give a very brief answer. -4.12e+08. What is the difference between the Value added (constant 2005 US$) of Eritrea in 2007 and the Value added (constant 2005 US$) of Timor-Leste in 2008?
Offer a terse response. 1.17e+08. What is the difference between the Value added (constant 2005 US$) of Malawi in 2007 and the Value added (constant 2005 US$) of Timor-Leste in 2008?
Your answer should be very brief. 4.43e+08. What is the difference between the Value added (constant 2005 US$) of Afghanistan in 2007 and the Value added (constant 2005 US$) of Eritrea in 2009?
Offer a very short reply. 1.82e+09. What is the difference between the Value added (constant 2005 US$) in Afghanistan in 2007 and the Value added (constant 2005 US$) in Malawi in 2009?
Give a very brief answer. 1.38e+09. What is the difference between the Value added (constant 2005 US$) of Afghanistan in 2007 and the Value added (constant 2005 US$) of Timor-Leste in 2009?
Provide a short and direct response. 1.90e+09. What is the difference between the Value added (constant 2005 US$) in Eritrea in 2007 and the Value added (constant 2005 US$) in Malawi in 2009?
Offer a terse response. -4.45e+08. What is the difference between the Value added (constant 2005 US$) of Eritrea in 2007 and the Value added (constant 2005 US$) of Timor-Leste in 2009?
Keep it short and to the point. 7.80e+07. What is the difference between the Value added (constant 2005 US$) of Malawi in 2007 and the Value added (constant 2005 US$) of Timor-Leste in 2009?
Offer a terse response. 4.04e+08. What is the difference between the Value added (constant 2005 US$) of Afghanistan in 2008 and the Value added (constant 2005 US$) of Eritrea in 2009?
Offer a terse response. 1.94e+09. What is the difference between the Value added (constant 2005 US$) in Afghanistan in 2008 and the Value added (constant 2005 US$) in Malawi in 2009?
Your answer should be very brief. 1.50e+09. What is the difference between the Value added (constant 2005 US$) in Afghanistan in 2008 and the Value added (constant 2005 US$) in Timor-Leste in 2009?
Offer a terse response. 2.02e+09. What is the difference between the Value added (constant 2005 US$) in Eritrea in 2008 and the Value added (constant 2005 US$) in Malawi in 2009?
Provide a succinct answer. -4.42e+08. What is the difference between the Value added (constant 2005 US$) of Eritrea in 2008 and the Value added (constant 2005 US$) of Timor-Leste in 2009?
Provide a short and direct response. 8.11e+07. What is the difference between the Value added (constant 2005 US$) of Malawi in 2008 and the Value added (constant 2005 US$) of Timor-Leste in 2009?
Your answer should be very brief. 4.90e+08. What is the average Value added (constant 2005 US$) in Afghanistan per year?
Offer a very short reply. 1.74e+09. What is the average Value added (constant 2005 US$) in Eritrea per year?
Make the answer very short. 2.20e+08. What is the average Value added (constant 2005 US$) of Malawi per year?
Offer a terse response. 4.80e+08. What is the average Value added (constant 2005 US$) of Timor-Leste per year?
Your answer should be compact. 6.55e+07. In the year 2002, what is the difference between the Value added (constant 2005 US$) in Afghanistan and Value added (constant 2005 US$) in Eritrea?
Give a very brief answer. 9.30e+08. In the year 2002, what is the difference between the Value added (constant 2005 US$) of Afghanistan and Value added (constant 2005 US$) of Malawi?
Provide a short and direct response. 7.94e+08. In the year 2002, what is the difference between the Value added (constant 2005 US$) in Afghanistan and Value added (constant 2005 US$) in Timor-Leste?
Offer a terse response. 1.07e+09. In the year 2002, what is the difference between the Value added (constant 2005 US$) in Eritrea and Value added (constant 2005 US$) in Malawi?
Your answer should be very brief. -1.36e+08. In the year 2002, what is the difference between the Value added (constant 2005 US$) of Eritrea and Value added (constant 2005 US$) of Timor-Leste?
Offer a very short reply. 1.42e+08. In the year 2002, what is the difference between the Value added (constant 2005 US$) in Malawi and Value added (constant 2005 US$) in Timor-Leste?
Provide a short and direct response. 2.77e+08. In the year 2003, what is the difference between the Value added (constant 2005 US$) of Afghanistan and Value added (constant 2005 US$) of Eritrea?
Keep it short and to the point. 1.02e+09. In the year 2003, what is the difference between the Value added (constant 2005 US$) of Afghanistan and Value added (constant 2005 US$) of Malawi?
Your answer should be compact. 8.73e+08. In the year 2003, what is the difference between the Value added (constant 2005 US$) of Afghanistan and Value added (constant 2005 US$) of Timor-Leste?
Make the answer very short. 1.20e+09. In the year 2003, what is the difference between the Value added (constant 2005 US$) of Eritrea and Value added (constant 2005 US$) of Malawi?
Make the answer very short. -1.45e+08. In the year 2003, what is the difference between the Value added (constant 2005 US$) in Eritrea and Value added (constant 2005 US$) in Timor-Leste?
Ensure brevity in your answer.  1.79e+08. In the year 2003, what is the difference between the Value added (constant 2005 US$) of Malawi and Value added (constant 2005 US$) of Timor-Leste?
Provide a short and direct response. 3.24e+08. In the year 2004, what is the difference between the Value added (constant 2005 US$) of Afghanistan and Value added (constant 2005 US$) of Eritrea?
Your answer should be very brief. 1.23e+09. In the year 2004, what is the difference between the Value added (constant 2005 US$) of Afghanistan and Value added (constant 2005 US$) of Malawi?
Offer a very short reply. 1.07e+09. In the year 2004, what is the difference between the Value added (constant 2005 US$) of Afghanistan and Value added (constant 2005 US$) of Timor-Leste?
Provide a succinct answer. 1.42e+09. In the year 2004, what is the difference between the Value added (constant 2005 US$) of Eritrea and Value added (constant 2005 US$) of Malawi?
Offer a very short reply. -1.52e+08. In the year 2004, what is the difference between the Value added (constant 2005 US$) in Eritrea and Value added (constant 2005 US$) in Timor-Leste?
Your answer should be compact. 1.97e+08. In the year 2004, what is the difference between the Value added (constant 2005 US$) of Malawi and Value added (constant 2005 US$) of Timor-Leste?
Your answer should be compact. 3.50e+08. In the year 2005, what is the difference between the Value added (constant 2005 US$) of Afghanistan and Value added (constant 2005 US$) of Eritrea?
Make the answer very short. 1.44e+09. In the year 2005, what is the difference between the Value added (constant 2005 US$) in Afghanistan and Value added (constant 2005 US$) in Malawi?
Offer a terse response. 1.24e+09. In the year 2005, what is the difference between the Value added (constant 2005 US$) of Afghanistan and Value added (constant 2005 US$) of Timor-Leste?
Provide a short and direct response. 1.62e+09. In the year 2005, what is the difference between the Value added (constant 2005 US$) of Eritrea and Value added (constant 2005 US$) of Malawi?
Provide a succinct answer. -2.02e+08. In the year 2005, what is the difference between the Value added (constant 2005 US$) of Eritrea and Value added (constant 2005 US$) of Timor-Leste?
Give a very brief answer. 1.78e+08. In the year 2005, what is the difference between the Value added (constant 2005 US$) of Malawi and Value added (constant 2005 US$) of Timor-Leste?
Your answer should be very brief. 3.80e+08. In the year 2006, what is the difference between the Value added (constant 2005 US$) of Afghanistan and Value added (constant 2005 US$) of Eritrea?
Provide a short and direct response. 1.69e+09. In the year 2006, what is the difference between the Value added (constant 2005 US$) of Afghanistan and Value added (constant 2005 US$) of Malawi?
Your answer should be compact. 1.42e+09. In the year 2006, what is the difference between the Value added (constant 2005 US$) in Afghanistan and Value added (constant 2005 US$) in Timor-Leste?
Offer a very short reply. 1.86e+09. In the year 2006, what is the difference between the Value added (constant 2005 US$) of Eritrea and Value added (constant 2005 US$) of Malawi?
Your answer should be compact. -2.63e+08. In the year 2006, what is the difference between the Value added (constant 2005 US$) in Eritrea and Value added (constant 2005 US$) in Timor-Leste?
Your answer should be very brief. 1.76e+08. In the year 2006, what is the difference between the Value added (constant 2005 US$) of Malawi and Value added (constant 2005 US$) of Timor-Leste?
Make the answer very short. 4.39e+08. In the year 2007, what is the difference between the Value added (constant 2005 US$) of Afghanistan and Value added (constant 2005 US$) of Eritrea?
Your answer should be very brief. 1.83e+09. In the year 2007, what is the difference between the Value added (constant 2005 US$) of Afghanistan and Value added (constant 2005 US$) of Malawi?
Your answer should be very brief. 1.50e+09. In the year 2007, what is the difference between the Value added (constant 2005 US$) in Afghanistan and Value added (constant 2005 US$) in Timor-Leste?
Ensure brevity in your answer.  1.99e+09. In the year 2007, what is the difference between the Value added (constant 2005 US$) of Eritrea and Value added (constant 2005 US$) of Malawi?
Provide a succinct answer. -3.26e+08. In the year 2007, what is the difference between the Value added (constant 2005 US$) in Eritrea and Value added (constant 2005 US$) in Timor-Leste?
Your answer should be very brief. 1.64e+08. In the year 2007, what is the difference between the Value added (constant 2005 US$) of Malawi and Value added (constant 2005 US$) of Timor-Leste?
Make the answer very short. 4.91e+08. In the year 2008, what is the difference between the Value added (constant 2005 US$) of Afghanistan and Value added (constant 2005 US$) of Eritrea?
Make the answer very short. 1.94e+09. In the year 2008, what is the difference between the Value added (constant 2005 US$) in Afghanistan and Value added (constant 2005 US$) in Malawi?
Your response must be concise. 1.53e+09. In the year 2008, what is the difference between the Value added (constant 2005 US$) in Afghanistan and Value added (constant 2005 US$) in Timor-Leste?
Your response must be concise. 2.06e+09. In the year 2008, what is the difference between the Value added (constant 2005 US$) in Eritrea and Value added (constant 2005 US$) in Malawi?
Your response must be concise. -4.09e+08. In the year 2008, what is the difference between the Value added (constant 2005 US$) in Eritrea and Value added (constant 2005 US$) in Timor-Leste?
Keep it short and to the point. 1.20e+08. In the year 2008, what is the difference between the Value added (constant 2005 US$) of Malawi and Value added (constant 2005 US$) of Timor-Leste?
Your answer should be very brief. 5.28e+08. In the year 2009, what is the difference between the Value added (constant 2005 US$) of Afghanistan and Value added (constant 2005 US$) of Eritrea?
Ensure brevity in your answer.  2.07e+09. In the year 2009, what is the difference between the Value added (constant 2005 US$) of Afghanistan and Value added (constant 2005 US$) of Malawi?
Your answer should be very brief. 1.63e+09. In the year 2009, what is the difference between the Value added (constant 2005 US$) of Afghanistan and Value added (constant 2005 US$) of Timor-Leste?
Make the answer very short. 2.15e+09. In the year 2009, what is the difference between the Value added (constant 2005 US$) in Eritrea and Value added (constant 2005 US$) in Malawi?
Your answer should be very brief. -4.43e+08. In the year 2009, what is the difference between the Value added (constant 2005 US$) in Eritrea and Value added (constant 2005 US$) in Timor-Leste?
Offer a very short reply. 8.06e+07. In the year 2009, what is the difference between the Value added (constant 2005 US$) of Malawi and Value added (constant 2005 US$) of Timor-Leste?
Provide a succinct answer. 5.23e+08. What is the ratio of the Value added (constant 2005 US$) of Afghanistan in 2002 to that in 2003?
Keep it short and to the point. 0.91. What is the ratio of the Value added (constant 2005 US$) of Malawi in 2002 to that in 2003?
Give a very brief answer. 0.9. What is the ratio of the Value added (constant 2005 US$) in Timor-Leste in 2002 to that in 2003?
Offer a terse response. 1.16. What is the ratio of the Value added (constant 2005 US$) of Afghanistan in 2002 to that in 2004?
Offer a very short reply. 0.77. What is the ratio of the Value added (constant 2005 US$) of Eritrea in 2002 to that in 2004?
Keep it short and to the point. 0.84. What is the ratio of the Value added (constant 2005 US$) of Malawi in 2002 to that in 2004?
Offer a terse response. 0.86. What is the ratio of the Value added (constant 2005 US$) of Timor-Leste in 2002 to that in 2004?
Provide a succinct answer. 1.34. What is the ratio of the Value added (constant 2005 US$) in Afghanistan in 2002 to that in 2005?
Provide a short and direct response. 0.68. What is the ratio of the Value added (constant 2005 US$) in Eritrea in 2002 to that in 2005?
Give a very brief answer. 0.92. What is the ratio of the Value added (constant 2005 US$) in Malawi in 2002 to that in 2005?
Make the answer very short. 0.81. What is the ratio of the Value added (constant 2005 US$) in Timor-Leste in 2002 to that in 2005?
Your answer should be very brief. 1.41. What is the ratio of the Value added (constant 2005 US$) in Afghanistan in 2002 to that in 2006?
Give a very brief answer. 0.6. What is the ratio of the Value added (constant 2005 US$) in Malawi in 2002 to that in 2006?
Provide a short and direct response. 0.73. What is the ratio of the Value added (constant 2005 US$) in Timor-Leste in 2002 to that in 2006?
Offer a terse response. 2.14. What is the ratio of the Value added (constant 2005 US$) of Afghanistan in 2002 to that in 2007?
Your response must be concise. 0.56. What is the ratio of the Value added (constant 2005 US$) of Eritrea in 2002 to that in 2007?
Give a very brief answer. 0.99. What is the ratio of the Value added (constant 2005 US$) of Malawi in 2002 to that in 2007?
Provide a succinct answer. 0.64. What is the ratio of the Value added (constant 2005 US$) in Timor-Leste in 2002 to that in 2007?
Give a very brief answer. 1.44. What is the ratio of the Value added (constant 2005 US$) in Afghanistan in 2002 to that in 2008?
Keep it short and to the point. 0.53. What is the ratio of the Value added (constant 2005 US$) of Eritrea in 2002 to that in 2008?
Keep it short and to the point. 0.97. What is the ratio of the Value added (constant 2005 US$) in Malawi in 2002 to that in 2008?
Ensure brevity in your answer.  0.55. What is the ratio of the Value added (constant 2005 US$) of Timor-Leste in 2002 to that in 2008?
Make the answer very short. 0.71. What is the ratio of the Value added (constant 2005 US$) of Afghanistan in 2002 to that in 2009?
Make the answer very short. 0.5. What is the ratio of the Value added (constant 2005 US$) in Eritrea in 2002 to that in 2009?
Provide a succinct answer. 0.98. What is the ratio of the Value added (constant 2005 US$) of Malawi in 2002 to that in 2009?
Your answer should be very brief. 0.52. What is the ratio of the Value added (constant 2005 US$) in Timor-Leste in 2002 to that in 2009?
Your answer should be compact. 0.5. What is the ratio of the Value added (constant 2005 US$) of Afghanistan in 2003 to that in 2004?
Give a very brief answer. 0.85. What is the ratio of the Value added (constant 2005 US$) in Eritrea in 2003 to that in 2004?
Offer a terse response. 0.96. What is the ratio of the Value added (constant 2005 US$) of Malawi in 2003 to that in 2004?
Offer a terse response. 0.95. What is the ratio of the Value added (constant 2005 US$) of Timor-Leste in 2003 to that in 2004?
Provide a succinct answer. 1.15. What is the ratio of the Value added (constant 2005 US$) of Afghanistan in 2003 to that in 2005?
Offer a terse response. 0.75. What is the ratio of the Value added (constant 2005 US$) of Eritrea in 2003 to that in 2005?
Provide a short and direct response. 1.05. What is the ratio of the Value added (constant 2005 US$) in Malawi in 2003 to that in 2005?
Your response must be concise. 0.89. What is the ratio of the Value added (constant 2005 US$) of Timor-Leste in 2003 to that in 2005?
Provide a succinct answer. 1.21. What is the ratio of the Value added (constant 2005 US$) of Afghanistan in 2003 to that in 2006?
Your response must be concise. 0.66. What is the ratio of the Value added (constant 2005 US$) in Eritrea in 2003 to that in 2006?
Keep it short and to the point. 1.14. What is the ratio of the Value added (constant 2005 US$) of Malawi in 2003 to that in 2006?
Make the answer very short. 0.81. What is the ratio of the Value added (constant 2005 US$) of Timor-Leste in 2003 to that in 2006?
Provide a succinct answer. 1.84. What is the ratio of the Value added (constant 2005 US$) in Afghanistan in 2003 to that in 2007?
Offer a very short reply. 0.62. What is the ratio of the Value added (constant 2005 US$) of Eritrea in 2003 to that in 2007?
Make the answer very short. 1.12. What is the ratio of the Value added (constant 2005 US$) of Malawi in 2003 to that in 2007?
Ensure brevity in your answer.  0.71. What is the ratio of the Value added (constant 2005 US$) of Timor-Leste in 2003 to that in 2007?
Provide a succinct answer. 1.24. What is the ratio of the Value added (constant 2005 US$) in Afghanistan in 2003 to that in 2008?
Give a very brief answer. 0.58. What is the ratio of the Value added (constant 2005 US$) in Eritrea in 2003 to that in 2008?
Keep it short and to the point. 1.11. What is the ratio of the Value added (constant 2005 US$) of Malawi in 2003 to that in 2008?
Your answer should be compact. 0.61. What is the ratio of the Value added (constant 2005 US$) in Timor-Leste in 2003 to that in 2008?
Your response must be concise. 0.61. What is the ratio of the Value added (constant 2005 US$) in Afghanistan in 2003 to that in 2009?
Offer a very short reply. 0.55. What is the ratio of the Value added (constant 2005 US$) in Eritrea in 2003 to that in 2009?
Give a very brief answer. 1.11. What is the ratio of the Value added (constant 2005 US$) of Malawi in 2003 to that in 2009?
Offer a terse response. 0.58. What is the ratio of the Value added (constant 2005 US$) of Timor-Leste in 2003 to that in 2009?
Give a very brief answer. 0.43. What is the ratio of the Value added (constant 2005 US$) in Afghanistan in 2004 to that in 2005?
Your response must be concise. 0.89. What is the ratio of the Value added (constant 2005 US$) in Eritrea in 2004 to that in 2005?
Offer a very short reply. 1.1. What is the ratio of the Value added (constant 2005 US$) of Malawi in 2004 to that in 2005?
Your response must be concise. 0.94. What is the ratio of the Value added (constant 2005 US$) in Timor-Leste in 2004 to that in 2005?
Give a very brief answer. 1.05. What is the ratio of the Value added (constant 2005 US$) of Afghanistan in 2004 to that in 2006?
Give a very brief answer. 0.78. What is the ratio of the Value added (constant 2005 US$) of Eritrea in 2004 to that in 2006?
Give a very brief answer. 1.19. What is the ratio of the Value added (constant 2005 US$) in Malawi in 2004 to that in 2006?
Your answer should be compact. 0.85. What is the ratio of the Value added (constant 2005 US$) of Timor-Leste in 2004 to that in 2006?
Your answer should be compact. 1.59. What is the ratio of the Value added (constant 2005 US$) of Afghanistan in 2004 to that in 2007?
Give a very brief answer. 0.72. What is the ratio of the Value added (constant 2005 US$) of Eritrea in 2004 to that in 2007?
Your answer should be compact. 1.17. What is the ratio of the Value added (constant 2005 US$) of Malawi in 2004 to that in 2007?
Provide a succinct answer. 0.74. What is the ratio of the Value added (constant 2005 US$) in Timor-Leste in 2004 to that in 2007?
Your answer should be compact. 1.07. What is the ratio of the Value added (constant 2005 US$) in Afghanistan in 2004 to that in 2008?
Make the answer very short. 0.68. What is the ratio of the Value added (constant 2005 US$) of Eritrea in 2004 to that in 2008?
Offer a very short reply. 1.16. What is the ratio of the Value added (constant 2005 US$) in Malawi in 2004 to that in 2008?
Ensure brevity in your answer.  0.64. What is the ratio of the Value added (constant 2005 US$) in Timor-Leste in 2004 to that in 2008?
Your answer should be compact. 0.53. What is the ratio of the Value added (constant 2005 US$) of Afghanistan in 2004 to that in 2009?
Your response must be concise. 0.64. What is the ratio of the Value added (constant 2005 US$) of Eritrea in 2004 to that in 2009?
Provide a short and direct response. 1.16. What is the ratio of the Value added (constant 2005 US$) of Malawi in 2004 to that in 2009?
Your answer should be very brief. 0.61. What is the ratio of the Value added (constant 2005 US$) in Timor-Leste in 2004 to that in 2009?
Your answer should be compact. 0.37. What is the ratio of the Value added (constant 2005 US$) of Afghanistan in 2005 to that in 2006?
Offer a terse response. 0.88. What is the ratio of the Value added (constant 2005 US$) of Eritrea in 2005 to that in 2006?
Provide a succinct answer. 1.09. What is the ratio of the Value added (constant 2005 US$) of Malawi in 2005 to that in 2006?
Ensure brevity in your answer.  0.91. What is the ratio of the Value added (constant 2005 US$) in Timor-Leste in 2005 to that in 2006?
Make the answer very short. 1.51. What is the ratio of the Value added (constant 2005 US$) in Afghanistan in 2005 to that in 2007?
Provide a succinct answer. 0.82. What is the ratio of the Value added (constant 2005 US$) in Eritrea in 2005 to that in 2007?
Ensure brevity in your answer.  1.07. What is the ratio of the Value added (constant 2005 US$) in Malawi in 2005 to that in 2007?
Your answer should be compact. 0.8. What is the ratio of the Value added (constant 2005 US$) in Timor-Leste in 2005 to that in 2007?
Offer a terse response. 1.02. What is the ratio of the Value added (constant 2005 US$) in Afghanistan in 2005 to that in 2008?
Ensure brevity in your answer.  0.77. What is the ratio of the Value added (constant 2005 US$) in Eritrea in 2005 to that in 2008?
Keep it short and to the point. 1.05. What is the ratio of the Value added (constant 2005 US$) in Malawi in 2005 to that in 2008?
Offer a very short reply. 0.69. What is the ratio of the Value added (constant 2005 US$) in Afghanistan in 2005 to that in 2009?
Make the answer very short. 0.73. What is the ratio of the Value added (constant 2005 US$) in Eritrea in 2005 to that in 2009?
Offer a terse response. 1.05. What is the ratio of the Value added (constant 2005 US$) in Malawi in 2005 to that in 2009?
Offer a very short reply. 0.65. What is the ratio of the Value added (constant 2005 US$) in Timor-Leste in 2005 to that in 2009?
Provide a succinct answer. 0.35. What is the ratio of the Value added (constant 2005 US$) of Afghanistan in 2006 to that in 2007?
Offer a terse response. 0.93. What is the ratio of the Value added (constant 2005 US$) in Eritrea in 2006 to that in 2007?
Your response must be concise. 0.98. What is the ratio of the Value added (constant 2005 US$) of Malawi in 2006 to that in 2007?
Offer a very short reply. 0.88. What is the ratio of the Value added (constant 2005 US$) of Timor-Leste in 2006 to that in 2007?
Offer a very short reply. 0.67. What is the ratio of the Value added (constant 2005 US$) of Afghanistan in 2006 to that in 2008?
Make the answer very short. 0.88. What is the ratio of the Value added (constant 2005 US$) in Malawi in 2006 to that in 2008?
Make the answer very short. 0.76. What is the ratio of the Value added (constant 2005 US$) of Timor-Leste in 2006 to that in 2008?
Ensure brevity in your answer.  0.33. What is the ratio of the Value added (constant 2005 US$) of Afghanistan in 2006 to that in 2009?
Offer a terse response. 0.83. What is the ratio of the Value added (constant 2005 US$) of Eritrea in 2006 to that in 2009?
Offer a very short reply. 0.97. What is the ratio of the Value added (constant 2005 US$) in Malawi in 2006 to that in 2009?
Your answer should be very brief. 0.72. What is the ratio of the Value added (constant 2005 US$) of Timor-Leste in 2006 to that in 2009?
Make the answer very short. 0.23. What is the ratio of the Value added (constant 2005 US$) in Afghanistan in 2007 to that in 2008?
Ensure brevity in your answer.  0.95. What is the ratio of the Value added (constant 2005 US$) in Eritrea in 2007 to that in 2008?
Your answer should be compact. 0.99. What is the ratio of the Value added (constant 2005 US$) of Malawi in 2007 to that in 2008?
Keep it short and to the point. 0.86. What is the ratio of the Value added (constant 2005 US$) in Timor-Leste in 2007 to that in 2008?
Offer a terse response. 0.49. What is the ratio of the Value added (constant 2005 US$) in Afghanistan in 2007 to that in 2009?
Your answer should be compact. 0.89. What is the ratio of the Value added (constant 2005 US$) in Eritrea in 2007 to that in 2009?
Your response must be concise. 0.99. What is the ratio of the Value added (constant 2005 US$) of Malawi in 2007 to that in 2009?
Keep it short and to the point. 0.82. What is the ratio of the Value added (constant 2005 US$) in Timor-Leste in 2007 to that in 2009?
Your answer should be very brief. 0.35. What is the ratio of the Value added (constant 2005 US$) of Afghanistan in 2008 to that in 2009?
Offer a very short reply. 0.94. What is the ratio of the Value added (constant 2005 US$) in Malawi in 2008 to that in 2009?
Give a very brief answer. 0.95. What is the ratio of the Value added (constant 2005 US$) in Timor-Leste in 2008 to that in 2009?
Give a very brief answer. 0.71. What is the difference between the highest and the second highest Value added (constant 2005 US$) of Afghanistan?
Offer a very short reply. 1.32e+08. What is the difference between the highest and the second highest Value added (constant 2005 US$) in Eritrea?
Your answer should be very brief. 1.08e+07. What is the difference between the highest and the second highest Value added (constant 2005 US$) of Malawi?
Offer a terse response. 3.35e+07. What is the difference between the highest and the second highest Value added (constant 2005 US$) of Timor-Leste?
Your answer should be compact. 3.86e+07. What is the difference between the highest and the lowest Value added (constant 2005 US$) of Afghanistan?
Your answer should be compact. 1.15e+09. What is the difference between the highest and the lowest Value added (constant 2005 US$) in Eritrea?
Your answer should be compact. 4.00e+07. What is the difference between the highest and the lowest Value added (constant 2005 US$) in Malawi?
Give a very brief answer. 3.12e+08. What is the difference between the highest and the lowest Value added (constant 2005 US$) of Timor-Leste?
Provide a short and direct response. 1.02e+08. 